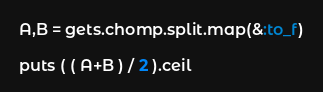Convert code to text. <code><loc_0><loc_0><loc_500><loc_500><_Ruby_>A,B = gets.chomp.split.map(&:to_f)

puts ( ( A+B ) / 2 ).ceil</code> 